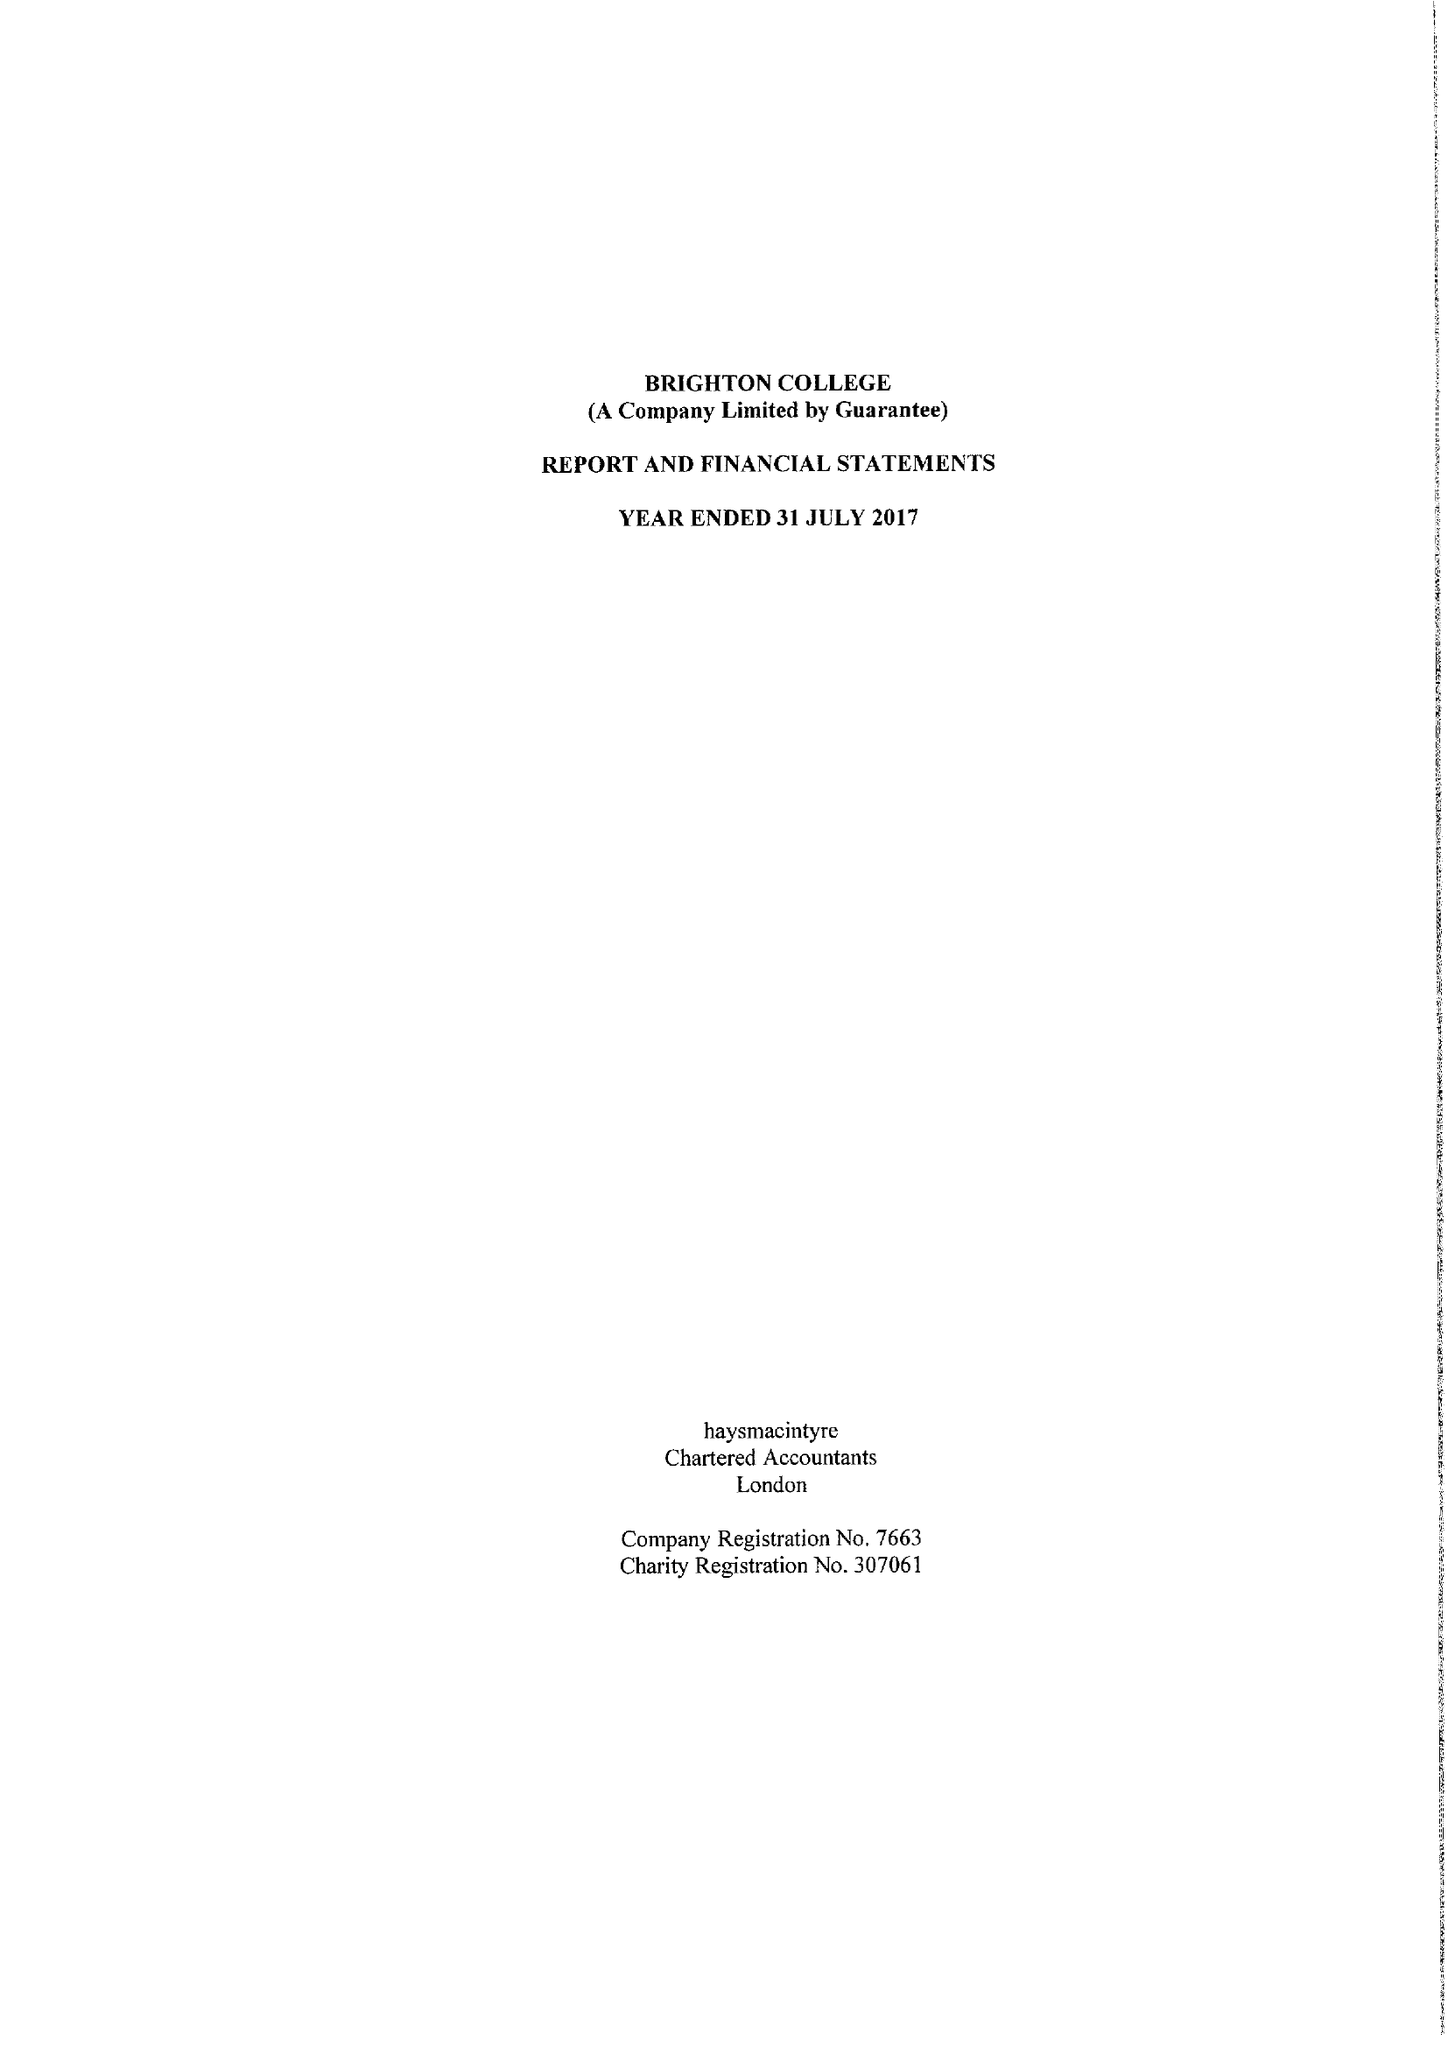What is the value for the charity_name?
Answer the question using a single word or phrase. Brighton College 